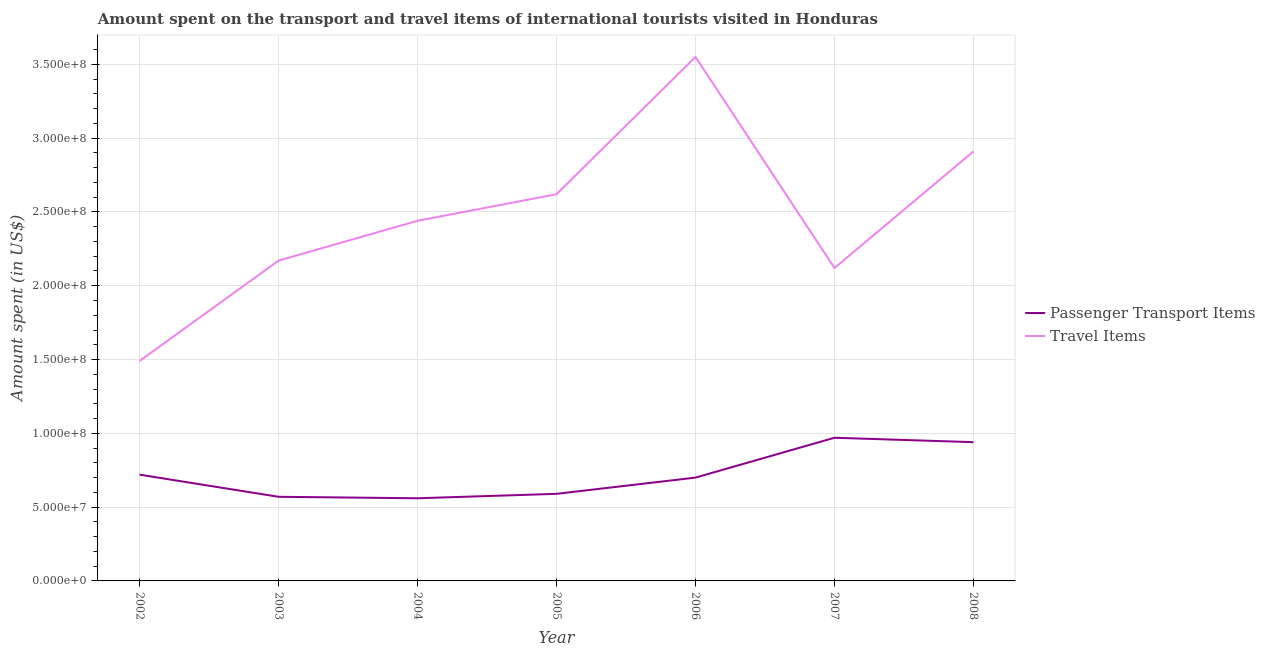Does the line corresponding to amount spent in travel items intersect with the line corresponding to amount spent on passenger transport items?
Make the answer very short. No. What is the amount spent in travel items in 2002?
Provide a succinct answer. 1.49e+08. Across all years, what is the maximum amount spent in travel items?
Provide a succinct answer. 3.55e+08. Across all years, what is the minimum amount spent in travel items?
Ensure brevity in your answer.  1.49e+08. What is the total amount spent on passenger transport items in the graph?
Offer a terse response. 5.05e+08. What is the difference between the amount spent on passenger transport items in 2002 and that in 2006?
Give a very brief answer. 2.00e+06. What is the difference between the amount spent on passenger transport items in 2004 and the amount spent in travel items in 2008?
Your answer should be very brief. -2.35e+08. What is the average amount spent in travel items per year?
Ensure brevity in your answer.  2.47e+08. In the year 2002, what is the difference between the amount spent on passenger transport items and amount spent in travel items?
Make the answer very short. -7.70e+07. In how many years, is the amount spent in travel items greater than 30000000 US$?
Keep it short and to the point. 7. What is the ratio of the amount spent on passenger transport items in 2004 to that in 2007?
Your answer should be compact. 0.58. What is the difference between the highest and the lowest amount spent in travel items?
Offer a very short reply. 2.06e+08. In how many years, is the amount spent on passenger transport items greater than the average amount spent on passenger transport items taken over all years?
Keep it short and to the point. 2. Is the sum of the amount spent in travel items in 2002 and 2004 greater than the maximum amount spent on passenger transport items across all years?
Your response must be concise. Yes. Is the amount spent in travel items strictly less than the amount spent on passenger transport items over the years?
Make the answer very short. No. How many lines are there?
Your response must be concise. 2. How many years are there in the graph?
Offer a very short reply. 7. What is the difference between two consecutive major ticks on the Y-axis?
Give a very brief answer. 5.00e+07. Are the values on the major ticks of Y-axis written in scientific E-notation?
Offer a terse response. Yes. Does the graph contain any zero values?
Your response must be concise. No. Does the graph contain grids?
Give a very brief answer. Yes. Where does the legend appear in the graph?
Provide a short and direct response. Center right. What is the title of the graph?
Offer a very short reply. Amount spent on the transport and travel items of international tourists visited in Honduras. What is the label or title of the X-axis?
Give a very brief answer. Year. What is the label or title of the Y-axis?
Offer a very short reply. Amount spent (in US$). What is the Amount spent (in US$) of Passenger Transport Items in 2002?
Ensure brevity in your answer.  7.20e+07. What is the Amount spent (in US$) in Travel Items in 2002?
Make the answer very short. 1.49e+08. What is the Amount spent (in US$) in Passenger Transport Items in 2003?
Keep it short and to the point. 5.70e+07. What is the Amount spent (in US$) in Travel Items in 2003?
Make the answer very short. 2.17e+08. What is the Amount spent (in US$) in Passenger Transport Items in 2004?
Your response must be concise. 5.60e+07. What is the Amount spent (in US$) of Travel Items in 2004?
Make the answer very short. 2.44e+08. What is the Amount spent (in US$) of Passenger Transport Items in 2005?
Provide a succinct answer. 5.90e+07. What is the Amount spent (in US$) in Travel Items in 2005?
Offer a very short reply. 2.62e+08. What is the Amount spent (in US$) in Passenger Transport Items in 2006?
Offer a terse response. 7.00e+07. What is the Amount spent (in US$) in Travel Items in 2006?
Offer a terse response. 3.55e+08. What is the Amount spent (in US$) in Passenger Transport Items in 2007?
Make the answer very short. 9.70e+07. What is the Amount spent (in US$) of Travel Items in 2007?
Provide a short and direct response. 2.12e+08. What is the Amount spent (in US$) of Passenger Transport Items in 2008?
Your answer should be very brief. 9.40e+07. What is the Amount spent (in US$) in Travel Items in 2008?
Offer a very short reply. 2.91e+08. Across all years, what is the maximum Amount spent (in US$) in Passenger Transport Items?
Make the answer very short. 9.70e+07. Across all years, what is the maximum Amount spent (in US$) in Travel Items?
Your answer should be very brief. 3.55e+08. Across all years, what is the minimum Amount spent (in US$) in Passenger Transport Items?
Provide a succinct answer. 5.60e+07. Across all years, what is the minimum Amount spent (in US$) in Travel Items?
Your answer should be compact. 1.49e+08. What is the total Amount spent (in US$) of Passenger Transport Items in the graph?
Make the answer very short. 5.05e+08. What is the total Amount spent (in US$) of Travel Items in the graph?
Provide a succinct answer. 1.73e+09. What is the difference between the Amount spent (in US$) of Passenger Transport Items in 2002 and that in 2003?
Provide a succinct answer. 1.50e+07. What is the difference between the Amount spent (in US$) of Travel Items in 2002 and that in 2003?
Ensure brevity in your answer.  -6.80e+07. What is the difference between the Amount spent (in US$) of Passenger Transport Items in 2002 and that in 2004?
Offer a very short reply. 1.60e+07. What is the difference between the Amount spent (in US$) of Travel Items in 2002 and that in 2004?
Provide a short and direct response. -9.50e+07. What is the difference between the Amount spent (in US$) in Passenger Transport Items in 2002 and that in 2005?
Provide a short and direct response. 1.30e+07. What is the difference between the Amount spent (in US$) in Travel Items in 2002 and that in 2005?
Provide a succinct answer. -1.13e+08. What is the difference between the Amount spent (in US$) of Travel Items in 2002 and that in 2006?
Give a very brief answer. -2.06e+08. What is the difference between the Amount spent (in US$) in Passenger Transport Items in 2002 and that in 2007?
Your response must be concise. -2.50e+07. What is the difference between the Amount spent (in US$) in Travel Items in 2002 and that in 2007?
Offer a very short reply. -6.30e+07. What is the difference between the Amount spent (in US$) of Passenger Transport Items in 2002 and that in 2008?
Your response must be concise. -2.20e+07. What is the difference between the Amount spent (in US$) of Travel Items in 2002 and that in 2008?
Your answer should be very brief. -1.42e+08. What is the difference between the Amount spent (in US$) in Travel Items in 2003 and that in 2004?
Provide a short and direct response. -2.70e+07. What is the difference between the Amount spent (in US$) in Travel Items in 2003 and that in 2005?
Your answer should be compact. -4.50e+07. What is the difference between the Amount spent (in US$) of Passenger Transport Items in 2003 and that in 2006?
Offer a terse response. -1.30e+07. What is the difference between the Amount spent (in US$) of Travel Items in 2003 and that in 2006?
Provide a short and direct response. -1.38e+08. What is the difference between the Amount spent (in US$) in Passenger Transport Items in 2003 and that in 2007?
Your answer should be compact. -4.00e+07. What is the difference between the Amount spent (in US$) of Travel Items in 2003 and that in 2007?
Make the answer very short. 5.00e+06. What is the difference between the Amount spent (in US$) in Passenger Transport Items in 2003 and that in 2008?
Your response must be concise. -3.70e+07. What is the difference between the Amount spent (in US$) of Travel Items in 2003 and that in 2008?
Make the answer very short. -7.40e+07. What is the difference between the Amount spent (in US$) of Passenger Transport Items in 2004 and that in 2005?
Your answer should be compact. -3.00e+06. What is the difference between the Amount spent (in US$) of Travel Items in 2004 and that in 2005?
Offer a terse response. -1.80e+07. What is the difference between the Amount spent (in US$) of Passenger Transport Items in 2004 and that in 2006?
Provide a short and direct response. -1.40e+07. What is the difference between the Amount spent (in US$) of Travel Items in 2004 and that in 2006?
Provide a succinct answer. -1.11e+08. What is the difference between the Amount spent (in US$) of Passenger Transport Items in 2004 and that in 2007?
Keep it short and to the point. -4.10e+07. What is the difference between the Amount spent (in US$) of Travel Items in 2004 and that in 2007?
Give a very brief answer. 3.20e+07. What is the difference between the Amount spent (in US$) of Passenger Transport Items in 2004 and that in 2008?
Offer a terse response. -3.80e+07. What is the difference between the Amount spent (in US$) of Travel Items in 2004 and that in 2008?
Make the answer very short. -4.70e+07. What is the difference between the Amount spent (in US$) in Passenger Transport Items in 2005 and that in 2006?
Offer a terse response. -1.10e+07. What is the difference between the Amount spent (in US$) of Travel Items in 2005 and that in 2006?
Give a very brief answer. -9.30e+07. What is the difference between the Amount spent (in US$) of Passenger Transport Items in 2005 and that in 2007?
Your answer should be compact. -3.80e+07. What is the difference between the Amount spent (in US$) in Travel Items in 2005 and that in 2007?
Make the answer very short. 5.00e+07. What is the difference between the Amount spent (in US$) in Passenger Transport Items in 2005 and that in 2008?
Your response must be concise. -3.50e+07. What is the difference between the Amount spent (in US$) in Travel Items in 2005 and that in 2008?
Keep it short and to the point. -2.90e+07. What is the difference between the Amount spent (in US$) of Passenger Transport Items in 2006 and that in 2007?
Your answer should be very brief. -2.70e+07. What is the difference between the Amount spent (in US$) in Travel Items in 2006 and that in 2007?
Provide a succinct answer. 1.43e+08. What is the difference between the Amount spent (in US$) of Passenger Transport Items in 2006 and that in 2008?
Your answer should be very brief. -2.40e+07. What is the difference between the Amount spent (in US$) of Travel Items in 2006 and that in 2008?
Offer a very short reply. 6.40e+07. What is the difference between the Amount spent (in US$) of Travel Items in 2007 and that in 2008?
Your response must be concise. -7.90e+07. What is the difference between the Amount spent (in US$) of Passenger Transport Items in 2002 and the Amount spent (in US$) of Travel Items in 2003?
Your answer should be compact. -1.45e+08. What is the difference between the Amount spent (in US$) of Passenger Transport Items in 2002 and the Amount spent (in US$) of Travel Items in 2004?
Offer a terse response. -1.72e+08. What is the difference between the Amount spent (in US$) in Passenger Transport Items in 2002 and the Amount spent (in US$) in Travel Items in 2005?
Provide a succinct answer. -1.90e+08. What is the difference between the Amount spent (in US$) in Passenger Transport Items in 2002 and the Amount spent (in US$) in Travel Items in 2006?
Offer a very short reply. -2.83e+08. What is the difference between the Amount spent (in US$) of Passenger Transport Items in 2002 and the Amount spent (in US$) of Travel Items in 2007?
Your answer should be compact. -1.40e+08. What is the difference between the Amount spent (in US$) in Passenger Transport Items in 2002 and the Amount spent (in US$) in Travel Items in 2008?
Your answer should be very brief. -2.19e+08. What is the difference between the Amount spent (in US$) of Passenger Transport Items in 2003 and the Amount spent (in US$) of Travel Items in 2004?
Your answer should be very brief. -1.87e+08. What is the difference between the Amount spent (in US$) of Passenger Transport Items in 2003 and the Amount spent (in US$) of Travel Items in 2005?
Your answer should be compact. -2.05e+08. What is the difference between the Amount spent (in US$) in Passenger Transport Items in 2003 and the Amount spent (in US$) in Travel Items in 2006?
Give a very brief answer. -2.98e+08. What is the difference between the Amount spent (in US$) of Passenger Transport Items in 2003 and the Amount spent (in US$) of Travel Items in 2007?
Offer a terse response. -1.55e+08. What is the difference between the Amount spent (in US$) in Passenger Transport Items in 2003 and the Amount spent (in US$) in Travel Items in 2008?
Provide a succinct answer. -2.34e+08. What is the difference between the Amount spent (in US$) of Passenger Transport Items in 2004 and the Amount spent (in US$) of Travel Items in 2005?
Give a very brief answer. -2.06e+08. What is the difference between the Amount spent (in US$) in Passenger Transport Items in 2004 and the Amount spent (in US$) in Travel Items in 2006?
Make the answer very short. -2.99e+08. What is the difference between the Amount spent (in US$) in Passenger Transport Items in 2004 and the Amount spent (in US$) in Travel Items in 2007?
Offer a terse response. -1.56e+08. What is the difference between the Amount spent (in US$) in Passenger Transport Items in 2004 and the Amount spent (in US$) in Travel Items in 2008?
Provide a short and direct response. -2.35e+08. What is the difference between the Amount spent (in US$) of Passenger Transport Items in 2005 and the Amount spent (in US$) of Travel Items in 2006?
Give a very brief answer. -2.96e+08. What is the difference between the Amount spent (in US$) in Passenger Transport Items in 2005 and the Amount spent (in US$) in Travel Items in 2007?
Make the answer very short. -1.53e+08. What is the difference between the Amount spent (in US$) in Passenger Transport Items in 2005 and the Amount spent (in US$) in Travel Items in 2008?
Your answer should be compact. -2.32e+08. What is the difference between the Amount spent (in US$) of Passenger Transport Items in 2006 and the Amount spent (in US$) of Travel Items in 2007?
Your answer should be compact. -1.42e+08. What is the difference between the Amount spent (in US$) in Passenger Transport Items in 2006 and the Amount spent (in US$) in Travel Items in 2008?
Your answer should be compact. -2.21e+08. What is the difference between the Amount spent (in US$) of Passenger Transport Items in 2007 and the Amount spent (in US$) of Travel Items in 2008?
Offer a terse response. -1.94e+08. What is the average Amount spent (in US$) in Passenger Transport Items per year?
Your answer should be compact. 7.21e+07. What is the average Amount spent (in US$) of Travel Items per year?
Give a very brief answer. 2.47e+08. In the year 2002, what is the difference between the Amount spent (in US$) in Passenger Transport Items and Amount spent (in US$) in Travel Items?
Your response must be concise. -7.70e+07. In the year 2003, what is the difference between the Amount spent (in US$) of Passenger Transport Items and Amount spent (in US$) of Travel Items?
Provide a succinct answer. -1.60e+08. In the year 2004, what is the difference between the Amount spent (in US$) of Passenger Transport Items and Amount spent (in US$) of Travel Items?
Give a very brief answer. -1.88e+08. In the year 2005, what is the difference between the Amount spent (in US$) of Passenger Transport Items and Amount spent (in US$) of Travel Items?
Make the answer very short. -2.03e+08. In the year 2006, what is the difference between the Amount spent (in US$) of Passenger Transport Items and Amount spent (in US$) of Travel Items?
Ensure brevity in your answer.  -2.85e+08. In the year 2007, what is the difference between the Amount spent (in US$) of Passenger Transport Items and Amount spent (in US$) of Travel Items?
Make the answer very short. -1.15e+08. In the year 2008, what is the difference between the Amount spent (in US$) of Passenger Transport Items and Amount spent (in US$) of Travel Items?
Give a very brief answer. -1.97e+08. What is the ratio of the Amount spent (in US$) of Passenger Transport Items in 2002 to that in 2003?
Your answer should be very brief. 1.26. What is the ratio of the Amount spent (in US$) of Travel Items in 2002 to that in 2003?
Provide a succinct answer. 0.69. What is the ratio of the Amount spent (in US$) in Travel Items in 2002 to that in 2004?
Make the answer very short. 0.61. What is the ratio of the Amount spent (in US$) in Passenger Transport Items in 2002 to that in 2005?
Offer a terse response. 1.22. What is the ratio of the Amount spent (in US$) in Travel Items in 2002 to that in 2005?
Keep it short and to the point. 0.57. What is the ratio of the Amount spent (in US$) of Passenger Transport Items in 2002 to that in 2006?
Offer a very short reply. 1.03. What is the ratio of the Amount spent (in US$) of Travel Items in 2002 to that in 2006?
Your answer should be very brief. 0.42. What is the ratio of the Amount spent (in US$) in Passenger Transport Items in 2002 to that in 2007?
Your answer should be compact. 0.74. What is the ratio of the Amount spent (in US$) in Travel Items in 2002 to that in 2007?
Your answer should be very brief. 0.7. What is the ratio of the Amount spent (in US$) of Passenger Transport Items in 2002 to that in 2008?
Make the answer very short. 0.77. What is the ratio of the Amount spent (in US$) of Travel Items in 2002 to that in 2008?
Ensure brevity in your answer.  0.51. What is the ratio of the Amount spent (in US$) in Passenger Transport Items in 2003 to that in 2004?
Provide a succinct answer. 1.02. What is the ratio of the Amount spent (in US$) in Travel Items in 2003 to that in 2004?
Make the answer very short. 0.89. What is the ratio of the Amount spent (in US$) of Passenger Transport Items in 2003 to that in 2005?
Provide a succinct answer. 0.97. What is the ratio of the Amount spent (in US$) in Travel Items in 2003 to that in 2005?
Provide a short and direct response. 0.83. What is the ratio of the Amount spent (in US$) of Passenger Transport Items in 2003 to that in 2006?
Keep it short and to the point. 0.81. What is the ratio of the Amount spent (in US$) in Travel Items in 2003 to that in 2006?
Give a very brief answer. 0.61. What is the ratio of the Amount spent (in US$) of Passenger Transport Items in 2003 to that in 2007?
Your answer should be very brief. 0.59. What is the ratio of the Amount spent (in US$) in Travel Items in 2003 to that in 2007?
Keep it short and to the point. 1.02. What is the ratio of the Amount spent (in US$) of Passenger Transport Items in 2003 to that in 2008?
Offer a very short reply. 0.61. What is the ratio of the Amount spent (in US$) of Travel Items in 2003 to that in 2008?
Provide a succinct answer. 0.75. What is the ratio of the Amount spent (in US$) of Passenger Transport Items in 2004 to that in 2005?
Make the answer very short. 0.95. What is the ratio of the Amount spent (in US$) in Travel Items in 2004 to that in 2005?
Provide a short and direct response. 0.93. What is the ratio of the Amount spent (in US$) of Passenger Transport Items in 2004 to that in 2006?
Offer a very short reply. 0.8. What is the ratio of the Amount spent (in US$) in Travel Items in 2004 to that in 2006?
Make the answer very short. 0.69. What is the ratio of the Amount spent (in US$) of Passenger Transport Items in 2004 to that in 2007?
Provide a succinct answer. 0.58. What is the ratio of the Amount spent (in US$) in Travel Items in 2004 to that in 2007?
Your answer should be very brief. 1.15. What is the ratio of the Amount spent (in US$) of Passenger Transport Items in 2004 to that in 2008?
Provide a short and direct response. 0.6. What is the ratio of the Amount spent (in US$) in Travel Items in 2004 to that in 2008?
Give a very brief answer. 0.84. What is the ratio of the Amount spent (in US$) of Passenger Transport Items in 2005 to that in 2006?
Offer a very short reply. 0.84. What is the ratio of the Amount spent (in US$) in Travel Items in 2005 to that in 2006?
Offer a terse response. 0.74. What is the ratio of the Amount spent (in US$) of Passenger Transport Items in 2005 to that in 2007?
Provide a succinct answer. 0.61. What is the ratio of the Amount spent (in US$) in Travel Items in 2005 to that in 2007?
Offer a terse response. 1.24. What is the ratio of the Amount spent (in US$) of Passenger Transport Items in 2005 to that in 2008?
Give a very brief answer. 0.63. What is the ratio of the Amount spent (in US$) of Travel Items in 2005 to that in 2008?
Give a very brief answer. 0.9. What is the ratio of the Amount spent (in US$) of Passenger Transport Items in 2006 to that in 2007?
Ensure brevity in your answer.  0.72. What is the ratio of the Amount spent (in US$) of Travel Items in 2006 to that in 2007?
Give a very brief answer. 1.67. What is the ratio of the Amount spent (in US$) in Passenger Transport Items in 2006 to that in 2008?
Your answer should be compact. 0.74. What is the ratio of the Amount spent (in US$) in Travel Items in 2006 to that in 2008?
Offer a very short reply. 1.22. What is the ratio of the Amount spent (in US$) of Passenger Transport Items in 2007 to that in 2008?
Your response must be concise. 1.03. What is the ratio of the Amount spent (in US$) of Travel Items in 2007 to that in 2008?
Your answer should be compact. 0.73. What is the difference between the highest and the second highest Amount spent (in US$) in Travel Items?
Your response must be concise. 6.40e+07. What is the difference between the highest and the lowest Amount spent (in US$) of Passenger Transport Items?
Offer a very short reply. 4.10e+07. What is the difference between the highest and the lowest Amount spent (in US$) in Travel Items?
Provide a short and direct response. 2.06e+08. 